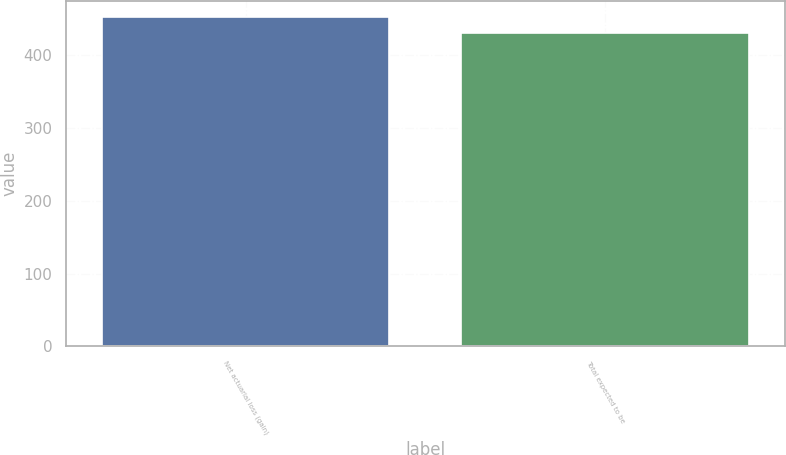Convert chart to OTSL. <chart><loc_0><loc_0><loc_500><loc_500><bar_chart><fcel>Net actuarial loss (gain)<fcel>Total expected to be<nl><fcel>452<fcel>430<nl></chart> 